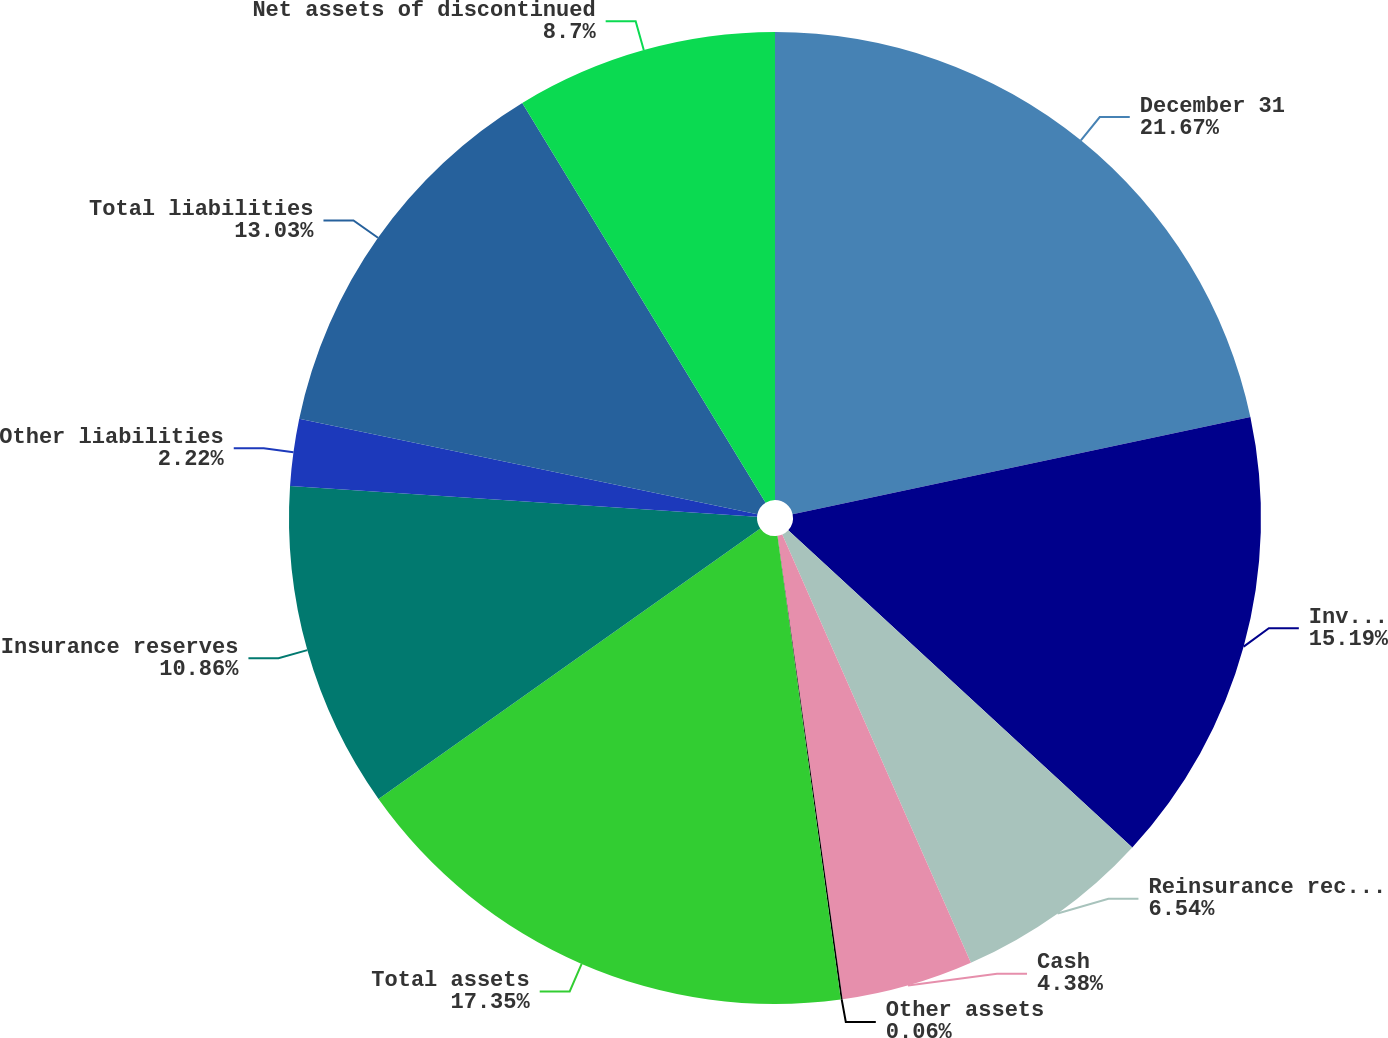<chart> <loc_0><loc_0><loc_500><loc_500><pie_chart><fcel>December 31<fcel>Investments<fcel>Reinsurance receivables<fcel>Cash<fcel>Other assets<fcel>Total assets<fcel>Insurance reserves<fcel>Other liabilities<fcel>Total liabilities<fcel>Net assets of discontinued<nl><fcel>21.66%<fcel>15.18%<fcel>6.54%<fcel>4.38%<fcel>0.06%<fcel>17.34%<fcel>10.86%<fcel>2.22%<fcel>13.02%<fcel>8.7%<nl></chart> 